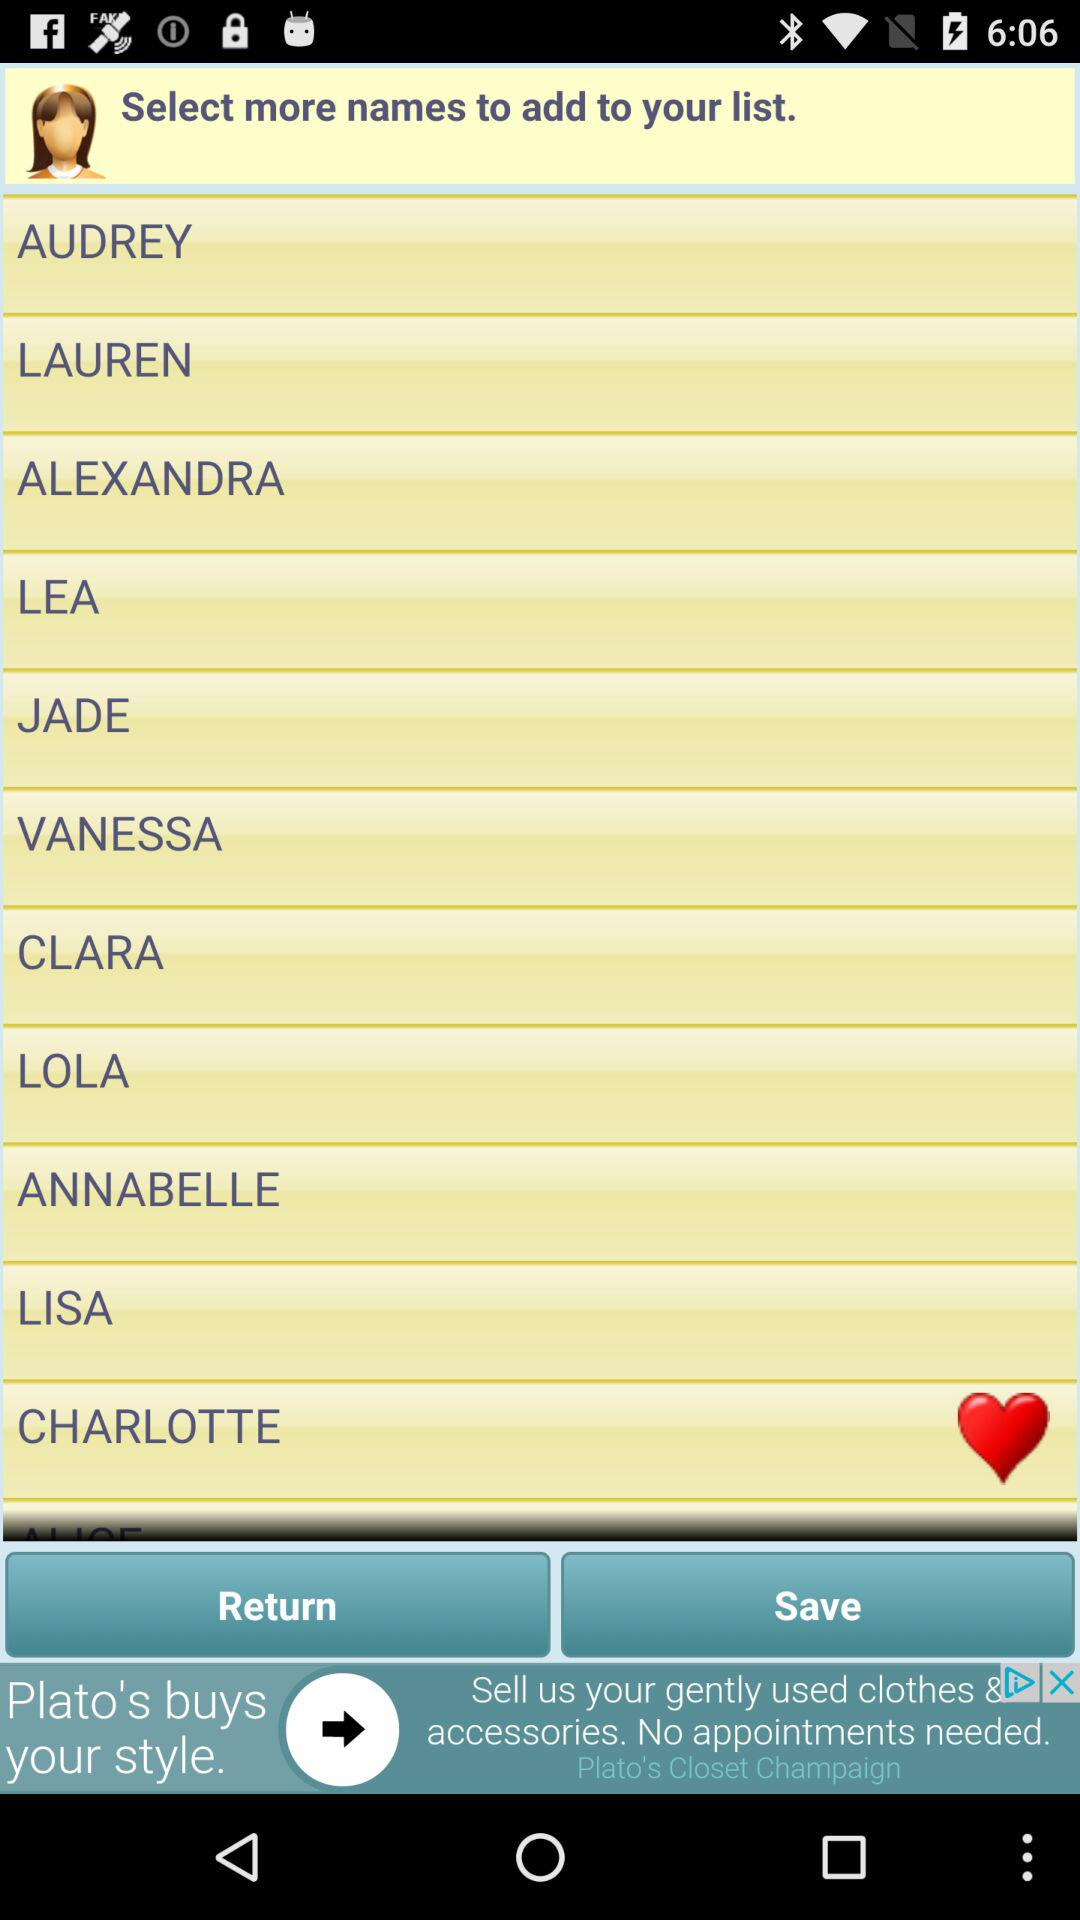What are the names on the list? The names displayed on the mobile app's list are: Audrey, Lauren, Alexandra, Lea, Jade, Vanessa, Clara, Lola, Annabelle, Lisa, and Charlotte. These names could possibly represent user preferences or choices in a profile customization setting of an application. 